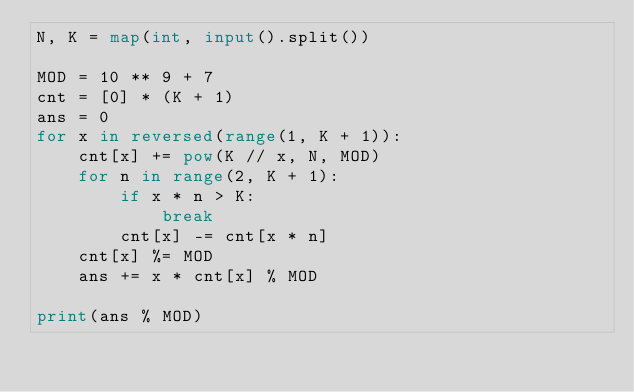Convert code to text. <code><loc_0><loc_0><loc_500><loc_500><_Python_>N, K = map(int, input().split())

MOD = 10 ** 9 + 7
cnt = [0] * (K + 1)
ans = 0
for x in reversed(range(1, K + 1)):
    cnt[x] += pow(K // x, N, MOD)
    for n in range(2, K + 1):
        if x * n > K:
            break
        cnt[x] -= cnt[x * n]
    cnt[x] %= MOD
    ans += x * cnt[x] % MOD

print(ans % MOD)
</code> 